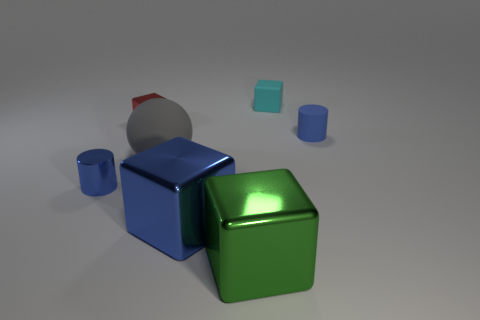Are there the same number of large blue objects in front of the big blue thing and blue objects?
Offer a very short reply. No. What number of cubes are the same material as the large blue thing?
Keep it short and to the point. 2. What is the color of the small cylinder that is made of the same material as the green thing?
Offer a terse response. Blue. Do the rubber cylinder and the blue cylinder left of the red shiny block have the same size?
Keep it short and to the point. Yes. The tiny cyan object has what shape?
Ensure brevity in your answer.  Cube. What number of tiny shiny cylinders have the same color as the large sphere?
Your answer should be very brief. 0. There is a tiny matte object that is the same shape as the tiny red shiny object; what color is it?
Your response must be concise. Cyan. How many small blocks are behind the blue cylinder that is in front of the ball?
Make the answer very short. 2. What number of spheres are either tiny metallic objects or large cyan metallic objects?
Give a very brief answer. 0. Are there any brown metallic spheres?
Provide a short and direct response. No. 